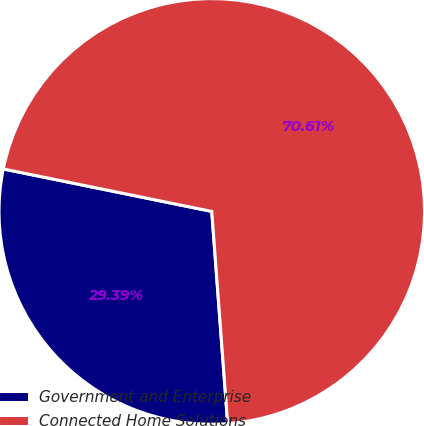<chart> <loc_0><loc_0><loc_500><loc_500><pie_chart><fcel>Government and Enterprise<fcel>Connected Home Solutions<nl><fcel>29.39%<fcel>70.61%<nl></chart> 